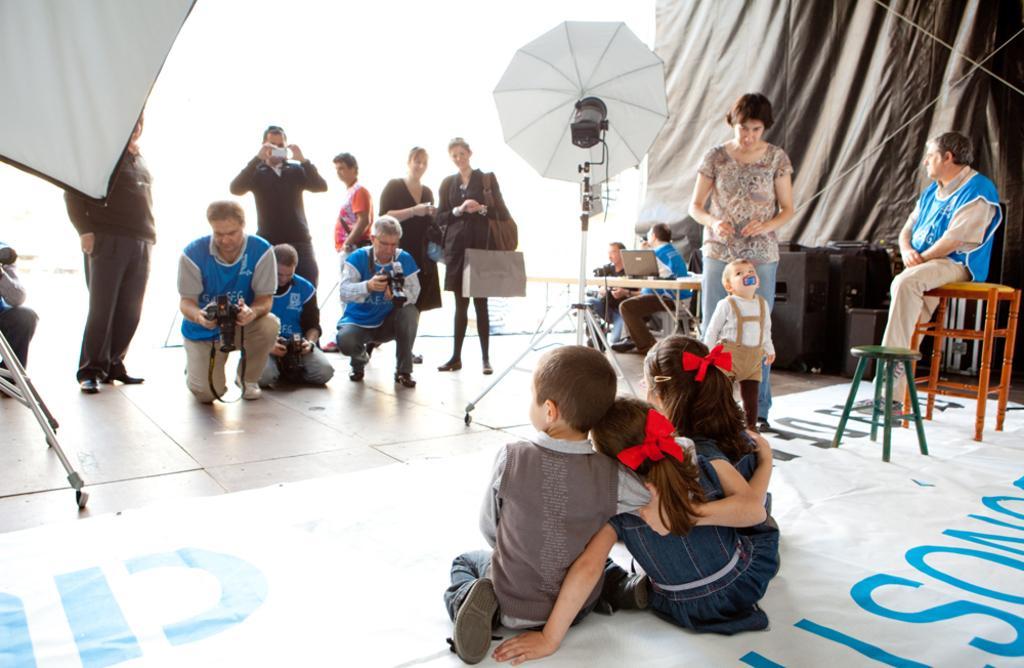In one or two sentences, can you explain what this image depicts? In the image there is a photo shoot is going on, there are few kids sitting on the floor and in front there are few men standing and clicking pictures in camera, on the right side there is table with laptop and few persons standing and sitting in front of speakers. 